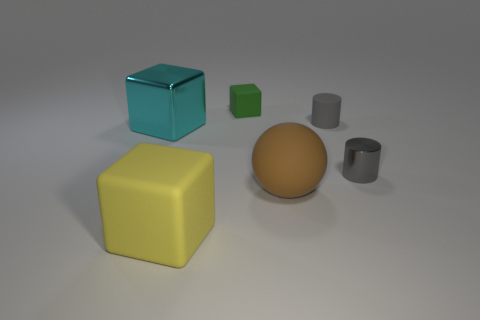Are the small green cube and the small cylinder behind the large cyan metal object made of the same material?
Ensure brevity in your answer.  Yes. Are there any brown rubber spheres that have the same size as the cyan metallic object?
Give a very brief answer. Yes. Are there the same number of green cubes that are in front of the yellow cube and large blocks?
Keep it short and to the point. No. What is the size of the green cube?
Give a very brief answer. Small. How many small cubes are to the left of the small gray thing behind the gray shiny thing?
Ensure brevity in your answer.  1. There is a thing that is both to the left of the green rubber block and on the right side of the shiny block; what is its shape?
Ensure brevity in your answer.  Cube. What number of matte cylinders are the same color as the tiny metal cylinder?
Offer a very short reply. 1. Is there a brown matte object that is behind the large cyan metallic cube that is behind the large cube in front of the tiny shiny cylinder?
Your answer should be compact. No. There is a matte object that is in front of the cyan metal object and right of the yellow matte thing; what is its size?
Your response must be concise. Large. How many other large brown objects are made of the same material as the brown thing?
Provide a short and direct response. 0. 